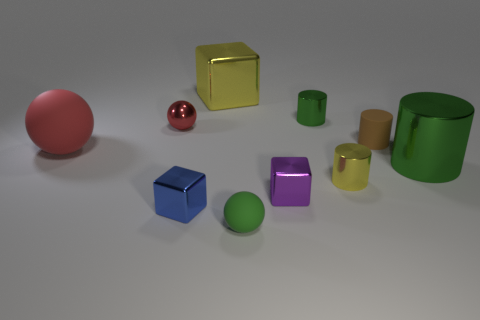Subtract 1 cubes. How many cubes are left? 2 Subtract all matte balls. How many balls are left? 1 Subtract all cyan cylinders. Subtract all cyan spheres. How many cylinders are left? 4 Subtract all balls. How many objects are left? 7 Subtract 0 blue cylinders. How many objects are left? 10 Subtract all big metal cubes. Subtract all small yellow things. How many objects are left? 8 Add 1 tiny purple blocks. How many tiny purple blocks are left? 2 Add 9 purple metal objects. How many purple metal objects exist? 10 